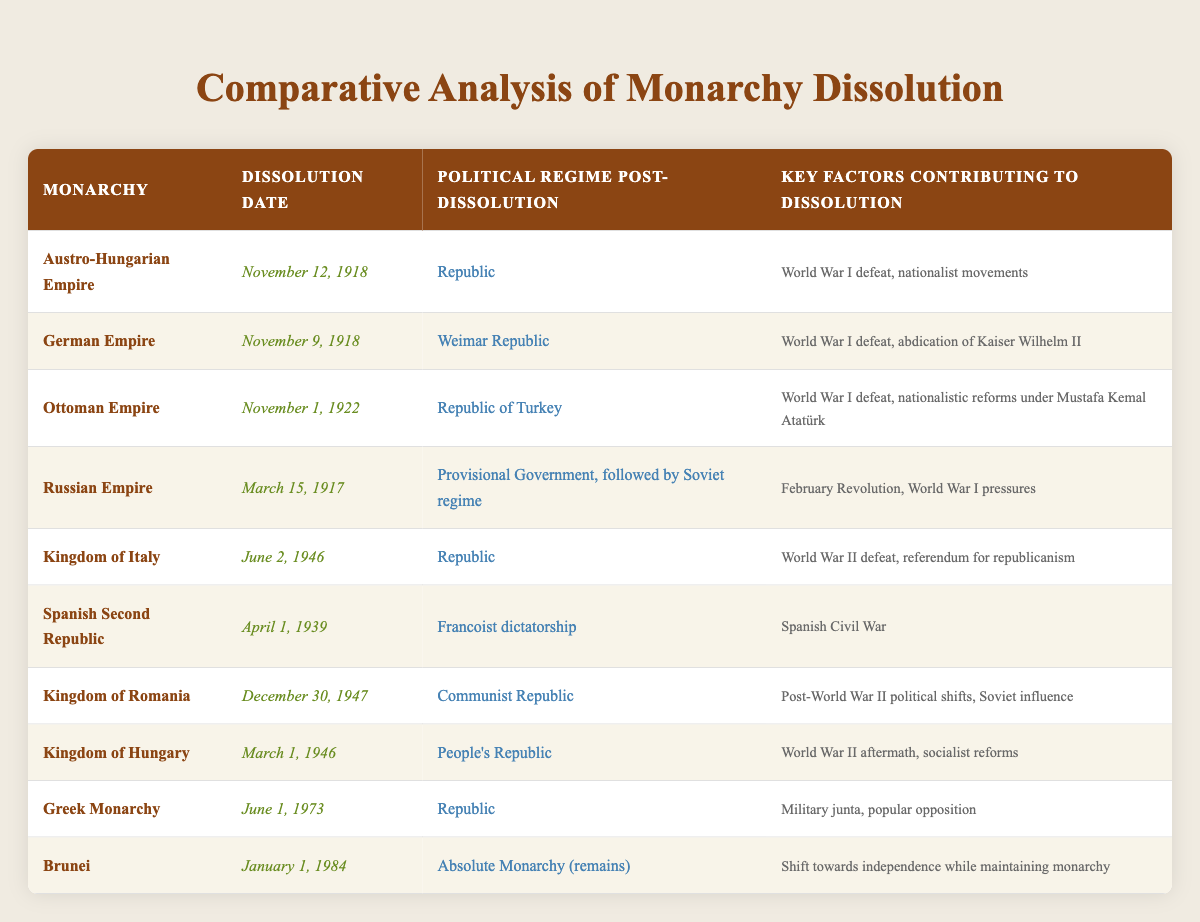What is the dissolution date of the German Empire? The table lists "November 9, 1918" as the dissolution date for the German Empire.
Answer: November 9, 1918 Which monarchy was dissolved most recently? According to the table, the most recent dissolution date is "January 1, 1984" for Brunei.
Answer: Brunei Does the Kingdom of Italy have a republican form of government post-dissolution? The table states that post-dissolution, the Kingdom of Italy became a Republic; therefore, the statement is true.
Answer: Yes What were the key factors contributing to the dissolution of the Ottoman Empire? By examining the table, it states that "World War I defeat" and "nationalistic reforms under Mustafa Kemal Atatürk" contributed to the dissolution.
Answer: World War I defeat, nationalistic reforms under Mustafa Kemal Atatürk How many monarchies transitioned directly to a form of republic after dissolution? The table shows 6 monarchies that transitioned to a republic: Austro-Hungarian Empire, German Empire, Kingdom of Italy, Greek Monarchy, and others. Adding those gives 6 transitions.
Answer: 6 What is the earliest dissolution date among those listed? The table indicates that the earliest dissolution date is "March 15, 1917" for the Russian Empire, which is before any other listed monarchy dissolution dates.
Answer: March 15, 1917 Which monarchy experienced a transition to a Francoist dictatorship? The table identifies the "Spanish Second Republic" as the monarchy that transitioned to a Francoist dictatorship post-dissolution.
Answer: Spanish Second Republic How did the dissolution of monarchies relate to major global conflicts? Analyzing the table, many dissolution dates are tied to major conflicts like World War I or World War II, indicating a correlation between these events and the fall of monarchies.
Answer: Many showed a correlation with World Wars What is the common factor in the dissolution of both the Austro-Hungarian Empire and the German Empire? Both empires dissolved following World War I defeat, which is mentioned in the table as a key contributing factor for each.
Answer: World War I defeat Which monarchy had a dissolution date closest to World War II? According to the table, the Kingdom of Italy dissolved on June 2, 1946, which is closest to the end of World War II in 1945.
Answer: Kingdom of Italy 